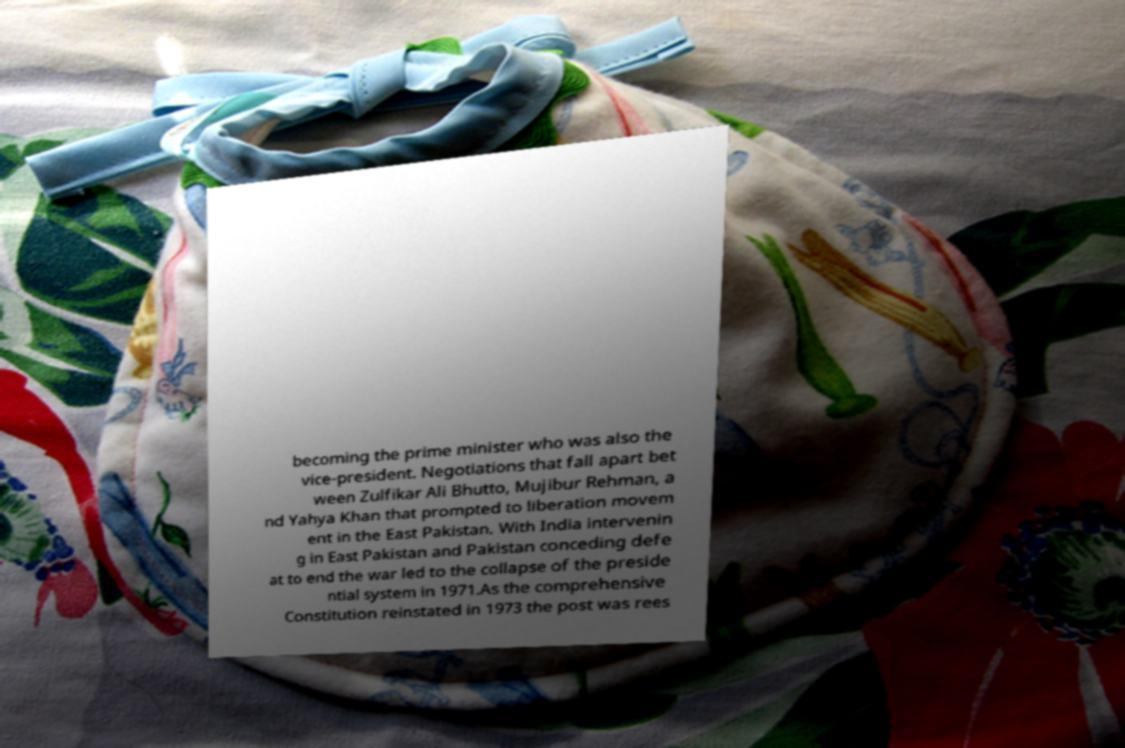I need the written content from this picture converted into text. Can you do that? becoming the prime minister who was also the vice-president. Negotiations that fall apart bet ween Zulfikar Ali Bhutto, Mujibur Rehman, a nd Yahya Khan that prompted to liberation movem ent in the East Pakistan. With India intervenin g in East Pakistan and Pakistan conceding defe at to end the war led to the collapse of the preside ntial system in 1971.As the comprehensive Constitution reinstated in 1973 the post was rees 